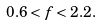<formula> <loc_0><loc_0><loc_500><loc_500>0 . 6 < f < 2 . 2 .</formula> 